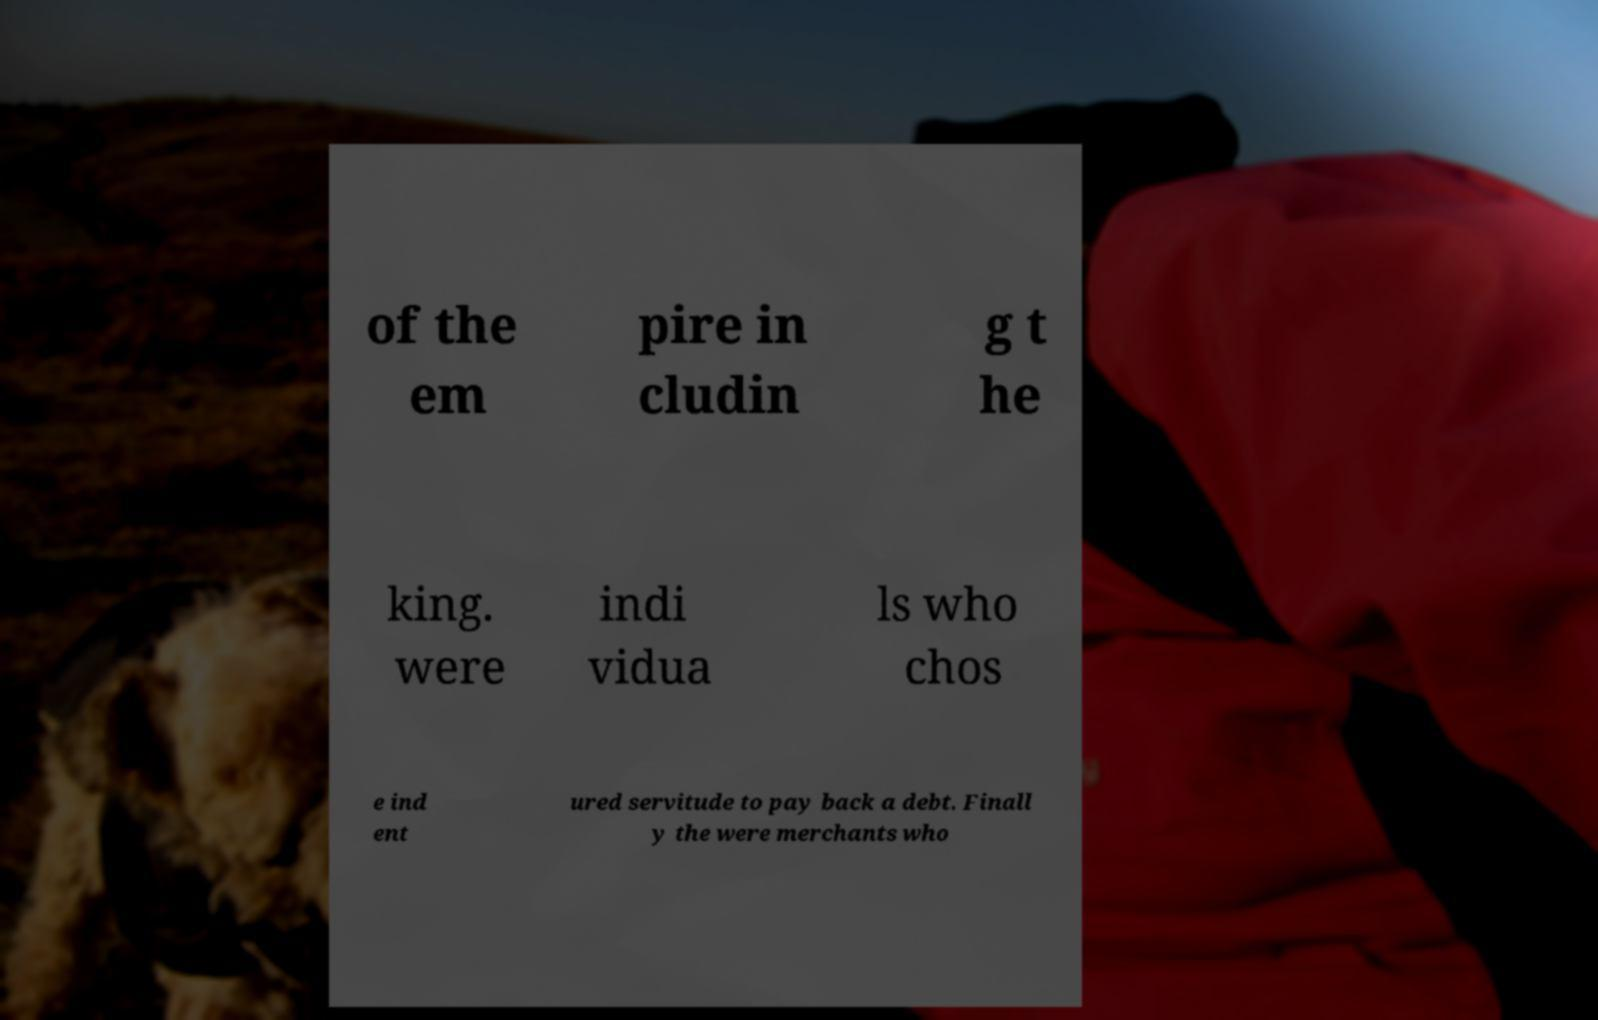There's text embedded in this image that I need extracted. Can you transcribe it verbatim? of the em pire in cludin g t he king. were indi vidua ls who chos e ind ent ured servitude to pay back a debt. Finall y the were merchants who 